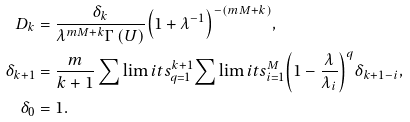<formula> <loc_0><loc_0><loc_500><loc_500>{ D _ { k } } & = \frac { \delta _ { k } } { { { \lambda ^ { m M + k } } \Gamma \left ( U \right ) } } { \left ( { 1 + { \lambda ^ { - 1 } } } \right ) ^ { - \left ( { m M + k } \right ) } } , \\ { \delta _ { k + 1 } } & = \frac { m } { k + 1 } \sum \lim i t s _ { q = 1 } ^ { k + 1 } { \sum \lim i t s _ { i = 1 } ^ { M } { { { \left ( { 1 - \frac { \lambda } { \lambda _ { i } } } \right ) } ^ { q } } } } { \delta _ { k + 1 - i } } , \\ { \delta _ { 0 } } & = 1 .</formula> 